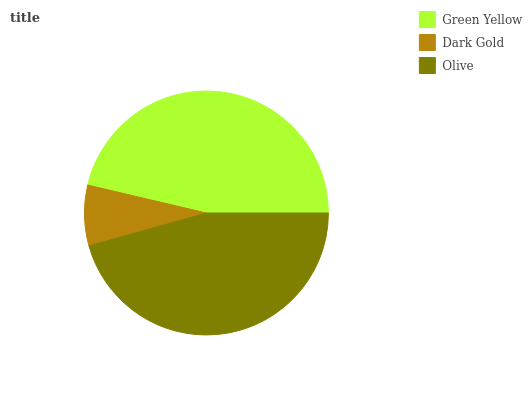Is Dark Gold the minimum?
Answer yes or no. Yes. Is Green Yellow the maximum?
Answer yes or no. Yes. Is Olive the minimum?
Answer yes or no. No. Is Olive the maximum?
Answer yes or no. No. Is Olive greater than Dark Gold?
Answer yes or no. Yes. Is Dark Gold less than Olive?
Answer yes or no. Yes. Is Dark Gold greater than Olive?
Answer yes or no. No. Is Olive less than Dark Gold?
Answer yes or no. No. Is Olive the high median?
Answer yes or no. Yes. Is Olive the low median?
Answer yes or no. Yes. Is Green Yellow the high median?
Answer yes or no. No. Is Dark Gold the low median?
Answer yes or no. No. 